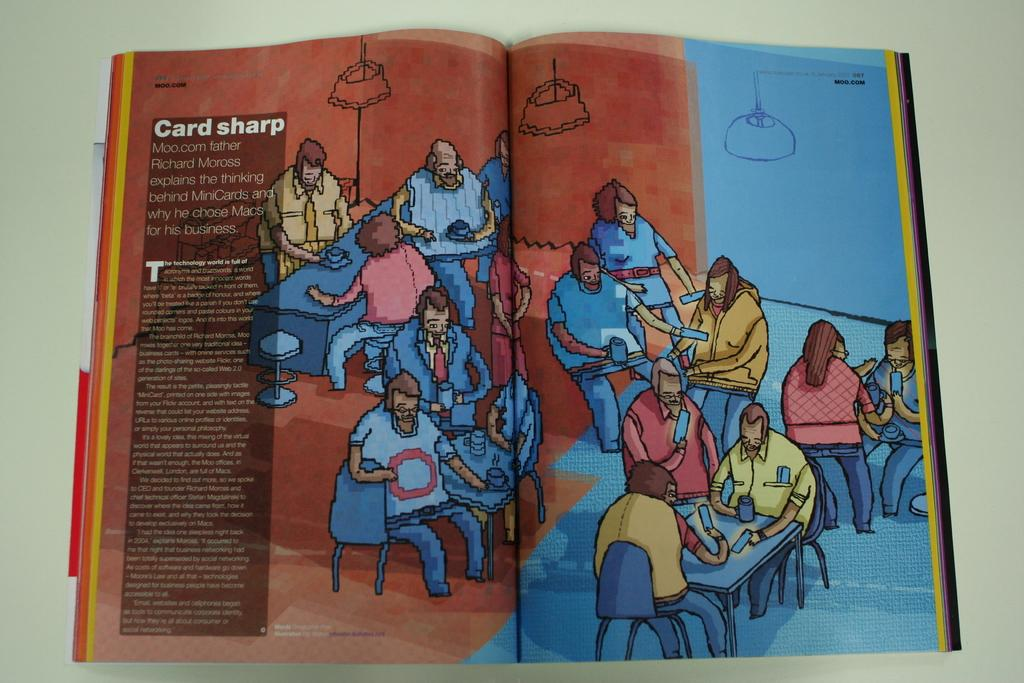<image>
Write a terse but informative summary of the picture. an open book with an excerpt that says card sharp with several drawings of people. 